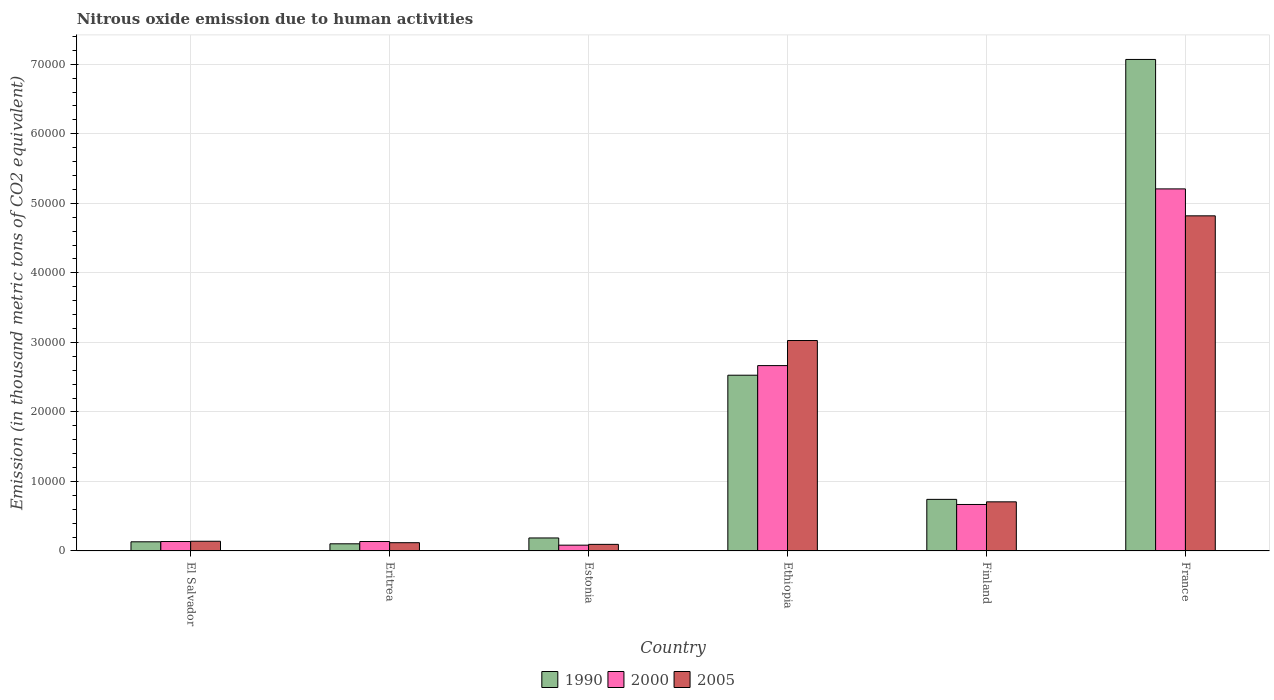How many different coloured bars are there?
Your response must be concise. 3. How many groups of bars are there?
Your response must be concise. 6. How many bars are there on the 5th tick from the left?
Your answer should be very brief. 3. How many bars are there on the 6th tick from the right?
Your answer should be very brief. 3. What is the label of the 1st group of bars from the left?
Your answer should be very brief. El Salvador. In how many cases, is the number of bars for a given country not equal to the number of legend labels?
Make the answer very short. 0. What is the amount of nitrous oxide emitted in 2000 in France?
Offer a very short reply. 5.21e+04. Across all countries, what is the maximum amount of nitrous oxide emitted in 2005?
Offer a very short reply. 4.82e+04. Across all countries, what is the minimum amount of nitrous oxide emitted in 2000?
Give a very brief answer. 837. In which country was the amount of nitrous oxide emitted in 1990 maximum?
Offer a very short reply. France. In which country was the amount of nitrous oxide emitted in 1990 minimum?
Your response must be concise. Eritrea. What is the total amount of nitrous oxide emitted in 2000 in the graph?
Give a very brief answer. 8.90e+04. What is the difference between the amount of nitrous oxide emitted in 2000 in El Salvador and that in Ethiopia?
Your answer should be very brief. -2.53e+04. What is the difference between the amount of nitrous oxide emitted in 2005 in Eritrea and the amount of nitrous oxide emitted in 2000 in Finland?
Keep it short and to the point. -5496.4. What is the average amount of nitrous oxide emitted in 2000 per country?
Provide a succinct answer. 1.48e+04. What is the difference between the amount of nitrous oxide emitted of/in 1990 and amount of nitrous oxide emitted of/in 2005 in Estonia?
Offer a very short reply. 921.2. What is the ratio of the amount of nitrous oxide emitted in 2005 in Finland to that in France?
Your answer should be compact. 0.15. Is the difference between the amount of nitrous oxide emitted in 1990 in El Salvador and Ethiopia greater than the difference between the amount of nitrous oxide emitted in 2005 in El Salvador and Ethiopia?
Provide a short and direct response. Yes. What is the difference between the highest and the second highest amount of nitrous oxide emitted in 2005?
Provide a succinct answer. 2.32e+04. What is the difference between the highest and the lowest amount of nitrous oxide emitted in 2005?
Your answer should be compact. 4.72e+04. How many bars are there?
Your response must be concise. 18. Are all the bars in the graph horizontal?
Make the answer very short. No. Are the values on the major ticks of Y-axis written in scientific E-notation?
Give a very brief answer. No. Does the graph contain any zero values?
Make the answer very short. No. How many legend labels are there?
Your answer should be very brief. 3. What is the title of the graph?
Make the answer very short. Nitrous oxide emission due to human activities. Does "1989" appear as one of the legend labels in the graph?
Offer a terse response. No. What is the label or title of the Y-axis?
Provide a succinct answer. Emission (in thousand metric tons of CO2 equivalent). What is the Emission (in thousand metric tons of CO2 equivalent) of 1990 in El Salvador?
Offer a very short reply. 1319.4. What is the Emission (in thousand metric tons of CO2 equivalent) of 2000 in El Salvador?
Your response must be concise. 1359.1. What is the Emission (in thousand metric tons of CO2 equivalent) in 2005 in El Salvador?
Your answer should be very brief. 1398.9. What is the Emission (in thousand metric tons of CO2 equivalent) in 1990 in Eritrea?
Your answer should be very brief. 1030.6. What is the Emission (in thousand metric tons of CO2 equivalent) in 2000 in Eritrea?
Offer a terse response. 1360.3. What is the Emission (in thousand metric tons of CO2 equivalent) of 2005 in Eritrea?
Provide a succinct answer. 1191.7. What is the Emission (in thousand metric tons of CO2 equivalent) of 1990 in Estonia?
Your answer should be very brief. 1872.9. What is the Emission (in thousand metric tons of CO2 equivalent) in 2000 in Estonia?
Provide a succinct answer. 837. What is the Emission (in thousand metric tons of CO2 equivalent) in 2005 in Estonia?
Ensure brevity in your answer.  951.7. What is the Emission (in thousand metric tons of CO2 equivalent) of 1990 in Ethiopia?
Your response must be concise. 2.53e+04. What is the Emission (in thousand metric tons of CO2 equivalent) in 2000 in Ethiopia?
Offer a terse response. 2.67e+04. What is the Emission (in thousand metric tons of CO2 equivalent) of 2005 in Ethiopia?
Offer a very short reply. 3.03e+04. What is the Emission (in thousand metric tons of CO2 equivalent) in 1990 in Finland?
Your answer should be very brief. 7423. What is the Emission (in thousand metric tons of CO2 equivalent) in 2000 in Finland?
Offer a very short reply. 6688.1. What is the Emission (in thousand metric tons of CO2 equivalent) of 2005 in Finland?
Provide a succinct answer. 7068. What is the Emission (in thousand metric tons of CO2 equivalent) of 1990 in France?
Your answer should be very brief. 7.07e+04. What is the Emission (in thousand metric tons of CO2 equivalent) of 2000 in France?
Your answer should be compact. 5.21e+04. What is the Emission (in thousand metric tons of CO2 equivalent) in 2005 in France?
Keep it short and to the point. 4.82e+04. Across all countries, what is the maximum Emission (in thousand metric tons of CO2 equivalent) of 1990?
Your response must be concise. 7.07e+04. Across all countries, what is the maximum Emission (in thousand metric tons of CO2 equivalent) of 2000?
Offer a very short reply. 5.21e+04. Across all countries, what is the maximum Emission (in thousand metric tons of CO2 equivalent) in 2005?
Give a very brief answer. 4.82e+04. Across all countries, what is the minimum Emission (in thousand metric tons of CO2 equivalent) in 1990?
Give a very brief answer. 1030.6. Across all countries, what is the minimum Emission (in thousand metric tons of CO2 equivalent) of 2000?
Your answer should be very brief. 837. Across all countries, what is the minimum Emission (in thousand metric tons of CO2 equivalent) in 2005?
Make the answer very short. 951.7. What is the total Emission (in thousand metric tons of CO2 equivalent) in 1990 in the graph?
Your answer should be very brief. 1.08e+05. What is the total Emission (in thousand metric tons of CO2 equivalent) in 2000 in the graph?
Offer a very short reply. 8.90e+04. What is the total Emission (in thousand metric tons of CO2 equivalent) of 2005 in the graph?
Your response must be concise. 8.91e+04. What is the difference between the Emission (in thousand metric tons of CO2 equivalent) in 1990 in El Salvador and that in Eritrea?
Your response must be concise. 288.8. What is the difference between the Emission (in thousand metric tons of CO2 equivalent) in 2000 in El Salvador and that in Eritrea?
Your answer should be compact. -1.2. What is the difference between the Emission (in thousand metric tons of CO2 equivalent) of 2005 in El Salvador and that in Eritrea?
Your answer should be compact. 207.2. What is the difference between the Emission (in thousand metric tons of CO2 equivalent) of 1990 in El Salvador and that in Estonia?
Provide a short and direct response. -553.5. What is the difference between the Emission (in thousand metric tons of CO2 equivalent) in 2000 in El Salvador and that in Estonia?
Offer a very short reply. 522.1. What is the difference between the Emission (in thousand metric tons of CO2 equivalent) of 2005 in El Salvador and that in Estonia?
Make the answer very short. 447.2. What is the difference between the Emission (in thousand metric tons of CO2 equivalent) of 1990 in El Salvador and that in Ethiopia?
Your answer should be compact. -2.40e+04. What is the difference between the Emission (in thousand metric tons of CO2 equivalent) of 2000 in El Salvador and that in Ethiopia?
Provide a short and direct response. -2.53e+04. What is the difference between the Emission (in thousand metric tons of CO2 equivalent) of 2005 in El Salvador and that in Ethiopia?
Provide a succinct answer. -2.89e+04. What is the difference between the Emission (in thousand metric tons of CO2 equivalent) in 1990 in El Salvador and that in Finland?
Your answer should be very brief. -6103.6. What is the difference between the Emission (in thousand metric tons of CO2 equivalent) in 2000 in El Salvador and that in Finland?
Offer a terse response. -5329. What is the difference between the Emission (in thousand metric tons of CO2 equivalent) of 2005 in El Salvador and that in Finland?
Make the answer very short. -5669.1. What is the difference between the Emission (in thousand metric tons of CO2 equivalent) of 1990 in El Salvador and that in France?
Ensure brevity in your answer.  -6.94e+04. What is the difference between the Emission (in thousand metric tons of CO2 equivalent) of 2000 in El Salvador and that in France?
Offer a very short reply. -5.07e+04. What is the difference between the Emission (in thousand metric tons of CO2 equivalent) in 2005 in El Salvador and that in France?
Keep it short and to the point. -4.68e+04. What is the difference between the Emission (in thousand metric tons of CO2 equivalent) of 1990 in Eritrea and that in Estonia?
Your answer should be compact. -842.3. What is the difference between the Emission (in thousand metric tons of CO2 equivalent) in 2000 in Eritrea and that in Estonia?
Your answer should be compact. 523.3. What is the difference between the Emission (in thousand metric tons of CO2 equivalent) of 2005 in Eritrea and that in Estonia?
Provide a succinct answer. 240. What is the difference between the Emission (in thousand metric tons of CO2 equivalent) of 1990 in Eritrea and that in Ethiopia?
Provide a short and direct response. -2.42e+04. What is the difference between the Emission (in thousand metric tons of CO2 equivalent) in 2000 in Eritrea and that in Ethiopia?
Keep it short and to the point. -2.53e+04. What is the difference between the Emission (in thousand metric tons of CO2 equivalent) in 2005 in Eritrea and that in Ethiopia?
Ensure brevity in your answer.  -2.91e+04. What is the difference between the Emission (in thousand metric tons of CO2 equivalent) in 1990 in Eritrea and that in Finland?
Provide a short and direct response. -6392.4. What is the difference between the Emission (in thousand metric tons of CO2 equivalent) in 2000 in Eritrea and that in Finland?
Provide a short and direct response. -5327.8. What is the difference between the Emission (in thousand metric tons of CO2 equivalent) in 2005 in Eritrea and that in Finland?
Provide a short and direct response. -5876.3. What is the difference between the Emission (in thousand metric tons of CO2 equivalent) in 1990 in Eritrea and that in France?
Give a very brief answer. -6.97e+04. What is the difference between the Emission (in thousand metric tons of CO2 equivalent) in 2000 in Eritrea and that in France?
Your response must be concise. -5.07e+04. What is the difference between the Emission (in thousand metric tons of CO2 equivalent) of 2005 in Eritrea and that in France?
Make the answer very short. -4.70e+04. What is the difference between the Emission (in thousand metric tons of CO2 equivalent) in 1990 in Estonia and that in Ethiopia?
Make the answer very short. -2.34e+04. What is the difference between the Emission (in thousand metric tons of CO2 equivalent) in 2000 in Estonia and that in Ethiopia?
Your response must be concise. -2.58e+04. What is the difference between the Emission (in thousand metric tons of CO2 equivalent) in 2005 in Estonia and that in Ethiopia?
Your answer should be very brief. -2.93e+04. What is the difference between the Emission (in thousand metric tons of CO2 equivalent) in 1990 in Estonia and that in Finland?
Give a very brief answer. -5550.1. What is the difference between the Emission (in thousand metric tons of CO2 equivalent) of 2000 in Estonia and that in Finland?
Offer a terse response. -5851.1. What is the difference between the Emission (in thousand metric tons of CO2 equivalent) of 2005 in Estonia and that in Finland?
Your answer should be very brief. -6116.3. What is the difference between the Emission (in thousand metric tons of CO2 equivalent) in 1990 in Estonia and that in France?
Provide a succinct answer. -6.88e+04. What is the difference between the Emission (in thousand metric tons of CO2 equivalent) in 2000 in Estonia and that in France?
Offer a terse response. -5.12e+04. What is the difference between the Emission (in thousand metric tons of CO2 equivalent) in 2005 in Estonia and that in France?
Offer a terse response. -4.72e+04. What is the difference between the Emission (in thousand metric tons of CO2 equivalent) of 1990 in Ethiopia and that in Finland?
Your response must be concise. 1.79e+04. What is the difference between the Emission (in thousand metric tons of CO2 equivalent) of 2000 in Ethiopia and that in Finland?
Your answer should be compact. 2.00e+04. What is the difference between the Emission (in thousand metric tons of CO2 equivalent) in 2005 in Ethiopia and that in Finland?
Offer a very short reply. 2.32e+04. What is the difference between the Emission (in thousand metric tons of CO2 equivalent) in 1990 in Ethiopia and that in France?
Keep it short and to the point. -4.54e+04. What is the difference between the Emission (in thousand metric tons of CO2 equivalent) of 2000 in Ethiopia and that in France?
Keep it short and to the point. -2.54e+04. What is the difference between the Emission (in thousand metric tons of CO2 equivalent) of 2005 in Ethiopia and that in France?
Ensure brevity in your answer.  -1.79e+04. What is the difference between the Emission (in thousand metric tons of CO2 equivalent) of 1990 in Finland and that in France?
Provide a succinct answer. -6.33e+04. What is the difference between the Emission (in thousand metric tons of CO2 equivalent) of 2000 in Finland and that in France?
Your answer should be compact. -4.54e+04. What is the difference between the Emission (in thousand metric tons of CO2 equivalent) of 2005 in Finland and that in France?
Your response must be concise. -4.11e+04. What is the difference between the Emission (in thousand metric tons of CO2 equivalent) in 1990 in El Salvador and the Emission (in thousand metric tons of CO2 equivalent) in 2000 in Eritrea?
Give a very brief answer. -40.9. What is the difference between the Emission (in thousand metric tons of CO2 equivalent) in 1990 in El Salvador and the Emission (in thousand metric tons of CO2 equivalent) in 2005 in Eritrea?
Provide a short and direct response. 127.7. What is the difference between the Emission (in thousand metric tons of CO2 equivalent) of 2000 in El Salvador and the Emission (in thousand metric tons of CO2 equivalent) of 2005 in Eritrea?
Provide a succinct answer. 167.4. What is the difference between the Emission (in thousand metric tons of CO2 equivalent) of 1990 in El Salvador and the Emission (in thousand metric tons of CO2 equivalent) of 2000 in Estonia?
Provide a succinct answer. 482.4. What is the difference between the Emission (in thousand metric tons of CO2 equivalent) of 1990 in El Salvador and the Emission (in thousand metric tons of CO2 equivalent) of 2005 in Estonia?
Keep it short and to the point. 367.7. What is the difference between the Emission (in thousand metric tons of CO2 equivalent) in 2000 in El Salvador and the Emission (in thousand metric tons of CO2 equivalent) in 2005 in Estonia?
Your response must be concise. 407.4. What is the difference between the Emission (in thousand metric tons of CO2 equivalent) in 1990 in El Salvador and the Emission (in thousand metric tons of CO2 equivalent) in 2000 in Ethiopia?
Your answer should be very brief. -2.53e+04. What is the difference between the Emission (in thousand metric tons of CO2 equivalent) of 1990 in El Salvador and the Emission (in thousand metric tons of CO2 equivalent) of 2005 in Ethiopia?
Your answer should be compact. -2.89e+04. What is the difference between the Emission (in thousand metric tons of CO2 equivalent) in 2000 in El Salvador and the Emission (in thousand metric tons of CO2 equivalent) in 2005 in Ethiopia?
Provide a succinct answer. -2.89e+04. What is the difference between the Emission (in thousand metric tons of CO2 equivalent) of 1990 in El Salvador and the Emission (in thousand metric tons of CO2 equivalent) of 2000 in Finland?
Keep it short and to the point. -5368.7. What is the difference between the Emission (in thousand metric tons of CO2 equivalent) of 1990 in El Salvador and the Emission (in thousand metric tons of CO2 equivalent) of 2005 in Finland?
Your response must be concise. -5748.6. What is the difference between the Emission (in thousand metric tons of CO2 equivalent) in 2000 in El Salvador and the Emission (in thousand metric tons of CO2 equivalent) in 2005 in Finland?
Provide a succinct answer. -5708.9. What is the difference between the Emission (in thousand metric tons of CO2 equivalent) of 1990 in El Salvador and the Emission (in thousand metric tons of CO2 equivalent) of 2000 in France?
Make the answer very short. -5.08e+04. What is the difference between the Emission (in thousand metric tons of CO2 equivalent) of 1990 in El Salvador and the Emission (in thousand metric tons of CO2 equivalent) of 2005 in France?
Ensure brevity in your answer.  -4.69e+04. What is the difference between the Emission (in thousand metric tons of CO2 equivalent) in 2000 in El Salvador and the Emission (in thousand metric tons of CO2 equivalent) in 2005 in France?
Your answer should be very brief. -4.68e+04. What is the difference between the Emission (in thousand metric tons of CO2 equivalent) of 1990 in Eritrea and the Emission (in thousand metric tons of CO2 equivalent) of 2000 in Estonia?
Provide a short and direct response. 193.6. What is the difference between the Emission (in thousand metric tons of CO2 equivalent) in 1990 in Eritrea and the Emission (in thousand metric tons of CO2 equivalent) in 2005 in Estonia?
Provide a succinct answer. 78.9. What is the difference between the Emission (in thousand metric tons of CO2 equivalent) in 2000 in Eritrea and the Emission (in thousand metric tons of CO2 equivalent) in 2005 in Estonia?
Give a very brief answer. 408.6. What is the difference between the Emission (in thousand metric tons of CO2 equivalent) in 1990 in Eritrea and the Emission (in thousand metric tons of CO2 equivalent) in 2000 in Ethiopia?
Ensure brevity in your answer.  -2.56e+04. What is the difference between the Emission (in thousand metric tons of CO2 equivalent) of 1990 in Eritrea and the Emission (in thousand metric tons of CO2 equivalent) of 2005 in Ethiopia?
Your response must be concise. -2.92e+04. What is the difference between the Emission (in thousand metric tons of CO2 equivalent) of 2000 in Eritrea and the Emission (in thousand metric tons of CO2 equivalent) of 2005 in Ethiopia?
Your answer should be very brief. -2.89e+04. What is the difference between the Emission (in thousand metric tons of CO2 equivalent) in 1990 in Eritrea and the Emission (in thousand metric tons of CO2 equivalent) in 2000 in Finland?
Offer a terse response. -5657.5. What is the difference between the Emission (in thousand metric tons of CO2 equivalent) in 1990 in Eritrea and the Emission (in thousand metric tons of CO2 equivalent) in 2005 in Finland?
Keep it short and to the point. -6037.4. What is the difference between the Emission (in thousand metric tons of CO2 equivalent) in 2000 in Eritrea and the Emission (in thousand metric tons of CO2 equivalent) in 2005 in Finland?
Provide a succinct answer. -5707.7. What is the difference between the Emission (in thousand metric tons of CO2 equivalent) of 1990 in Eritrea and the Emission (in thousand metric tons of CO2 equivalent) of 2000 in France?
Provide a short and direct response. -5.10e+04. What is the difference between the Emission (in thousand metric tons of CO2 equivalent) in 1990 in Eritrea and the Emission (in thousand metric tons of CO2 equivalent) in 2005 in France?
Make the answer very short. -4.72e+04. What is the difference between the Emission (in thousand metric tons of CO2 equivalent) in 2000 in Eritrea and the Emission (in thousand metric tons of CO2 equivalent) in 2005 in France?
Give a very brief answer. -4.68e+04. What is the difference between the Emission (in thousand metric tons of CO2 equivalent) of 1990 in Estonia and the Emission (in thousand metric tons of CO2 equivalent) of 2000 in Ethiopia?
Offer a terse response. -2.48e+04. What is the difference between the Emission (in thousand metric tons of CO2 equivalent) in 1990 in Estonia and the Emission (in thousand metric tons of CO2 equivalent) in 2005 in Ethiopia?
Give a very brief answer. -2.84e+04. What is the difference between the Emission (in thousand metric tons of CO2 equivalent) in 2000 in Estonia and the Emission (in thousand metric tons of CO2 equivalent) in 2005 in Ethiopia?
Your answer should be compact. -2.94e+04. What is the difference between the Emission (in thousand metric tons of CO2 equivalent) of 1990 in Estonia and the Emission (in thousand metric tons of CO2 equivalent) of 2000 in Finland?
Keep it short and to the point. -4815.2. What is the difference between the Emission (in thousand metric tons of CO2 equivalent) of 1990 in Estonia and the Emission (in thousand metric tons of CO2 equivalent) of 2005 in Finland?
Offer a terse response. -5195.1. What is the difference between the Emission (in thousand metric tons of CO2 equivalent) in 2000 in Estonia and the Emission (in thousand metric tons of CO2 equivalent) in 2005 in Finland?
Ensure brevity in your answer.  -6231. What is the difference between the Emission (in thousand metric tons of CO2 equivalent) in 1990 in Estonia and the Emission (in thousand metric tons of CO2 equivalent) in 2000 in France?
Your response must be concise. -5.02e+04. What is the difference between the Emission (in thousand metric tons of CO2 equivalent) in 1990 in Estonia and the Emission (in thousand metric tons of CO2 equivalent) in 2005 in France?
Offer a terse response. -4.63e+04. What is the difference between the Emission (in thousand metric tons of CO2 equivalent) in 2000 in Estonia and the Emission (in thousand metric tons of CO2 equivalent) in 2005 in France?
Give a very brief answer. -4.74e+04. What is the difference between the Emission (in thousand metric tons of CO2 equivalent) of 1990 in Ethiopia and the Emission (in thousand metric tons of CO2 equivalent) of 2000 in Finland?
Give a very brief answer. 1.86e+04. What is the difference between the Emission (in thousand metric tons of CO2 equivalent) in 1990 in Ethiopia and the Emission (in thousand metric tons of CO2 equivalent) in 2005 in Finland?
Offer a terse response. 1.82e+04. What is the difference between the Emission (in thousand metric tons of CO2 equivalent) of 2000 in Ethiopia and the Emission (in thousand metric tons of CO2 equivalent) of 2005 in Finland?
Ensure brevity in your answer.  1.96e+04. What is the difference between the Emission (in thousand metric tons of CO2 equivalent) of 1990 in Ethiopia and the Emission (in thousand metric tons of CO2 equivalent) of 2000 in France?
Offer a terse response. -2.68e+04. What is the difference between the Emission (in thousand metric tons of CO2 equivalent) in 1990 in Ethiopia and the Emission (in thousand metric tons of CO2 equivalent) in 2005 in France?
Make the answer very short. -2.29e+04. What is the difference between the Emission (in thousand metric tons of CO2 equivalent) in 2000 in Ethiopia and the Emission (in thousand metric tons of CO2 equivalent) in 2005 in France?
Give a very brief answer. -2.15e+04. What is the difference between the Emission (in thousand metric tons of CO2 equivalent) in 1990 in Finland and the Emission (in thousand metric tons of CO2 equivalent) in 2000 in France?
Provide a short and direct response. -4.47e+04. What is the difference between the Emission (in thousand metric tons of CO2 equivalent) in 1990 in Finland and the Emission (in thousand metric tons of CO2 equivalent) in 2005 in France?
Ensure brevity in your answer.  -4.08e+04. What is the difference between the Emission (in thousand metric tons of CO2 equivalent) of 2000 in Finland and the Emission (in thousand metric tons of CO2 equivalent) of 2005 in France?
Offer a terse response. -4.15e+04. What is the average Emission (in thousand metric tons of CO2 equivalent) in 1990 per country?
Your response must be concise. 1.79e+04. What is the average Emission (in thousand metric tons of CO2 equivalent) in 2000 per country?
Your answer should be very brief. 1.48e+04. What is the average Emission (in thousand metric tons of CO2 equivalent) in 2005 per country?
Offer a terse response. 1.48e+04. What is the difference between the Emission (in thousand metric tons of CO2 equivalent) in 1990 and Emission (in thousand metric tons of CO2 equivalent) in 2000 in El Salvador?
Ensure brevity in your answer.  -39.7. What is the difference between the Emission (in thousand metric tons of CO2 equivalent) in 1990 and Emission (in thousand metric tons of CO2 equivalent) in 2005 in El Salvador?
Your answer should be compact. -79.5. What is the difference between the Emission (in thousand metric tons of CO2 equivalent) of 2000 and Emission (in thousand metric tons of CO2 equivalent) of 2005 in El Salvador?
Provide a short and direct response. -39.8. What is the difference between the Emission (in thousand metric tons of CO2 equivalent) of 1990 and Emission (in thousand metric tons of CO2 equivalent) of 2000 in Eritrea?
Provide a short and direct response. -329.7. What is the difference between the Emission (in thousand metric tons of CO2 equivalent) of 1990 and Emission (in thousand metric tons of CO2 equivalent) of 2005 in Eritrea?
Your response must be concise. -161.1. What is the difference between the Emission (in thousand metric tons of CO2 equivalent) of 2000 and Emission (in thousand metric tons of CO2 equivalent) of 2005 in Eritrea?
Ensure brevity in your answer.  168.6. What is the difference between the Emission (in thousand metric tons of CO2 equivalent) of 1990 and Emission (in thousand metric tons of CO2 equivalent) of 2000 in Estonia?
Keep it short and to the point. 1035.9. What is the difference between the Emission (in thousand metric tons of CO2 equivalent) in 1990 and Emission (in thousand metric tons of CO2 equivalent) in 2005 in Estonia?
Your response must be concise. 921.2. What is the difference between the Emission (in thousand metric tons of CO2 equivalent) of 2000 and Emission (in thousand metric tons of CO2 equivalent) of 2005 in Estonia?
Make the answer very short. -114.7. What is the difference between the Emission (in thousand metric tons of CO2 equivalent) of 1990 and Emission (in thousand metric tons of CO2 equivalent) of 2000 in Ethiopia?
Keep it short and to the point. -1381.9. What is the difference between the Emission (in thousand metric tons of CO2 equivalent) in 1990 and Emission (in thousand metric tons of CO2 equivalent) in 2005 in Ethiopia?
Your response must be concise. -4988.6. What is the difference between the Emission (in thousand metric tons of CO2 equivalent) of 2000 and Emission (in thousand metric tons of CO2 equivalent) of 2005 in Ethiopia?
Ensure brevity in your answer.  -3606.7. What is the difference between the Emission (in thousand metric tons of CO2 equivalent) of 1990 and Emission (in thousand metric tons of CO2 equivalent) of 2000 in Finland?
Ensure brevity in your answer.  734.9. What is the difference between the Emission (in thousand metric tons of CO2 equivalent) of 1990 and Emission (in thousand metric tons of CO2 equivalent) of 2005 in Finland?
Provide a succinct answer. 355. What is the difference between the Emission (in thousand metric tons of CO2 equivalent) in 2000 and Emission (in thousand metric tons of CO2 equivalent) in 2005 in Finland?
Your response must be concise. -379.9. What is the difference between the Emission (in thousand metric tons of CO2 equivalent) in 1990 and Emission (in thousand metric tons of CO2 equivalent) in 2000 in France?
Provide a succinct answer. 1.86e+04. What is the difference between the Emission (in thousand metric tons of CO2 equivalent) of 1990 and Emission (in thousand metric tons of CO2 equivalent) of 2005 in France?
Offer a terse response. 2.25e+04. What is the difference between the Emission (in thousand metric tons of CO2 equivalent) of 2000 and Emission (in thousand metric tons of CO2 equivalent) of 2005 in France?
Your answer should be very brief. 3875.3. What is the ratio of the Emission (in thousand metric tons of CO2 equivalent) in 1990 in El Salvador to that in Eritrea?
Offer a terse response. 1.28. What is the ratio of the Emission (in thousand metric tons of CO2 equivalent) in 2000 in El Salvador to that in Eritrea?
Provide a short and direct response. 1. What is the ratio of the Emission (in thousand metric tons of CO2 equivalent) in 2005 in El Salvador to that in Eritrea?
Keep it short and to the point. 1.17. What is the ratio of the Emission (in thousand metric tons of CO2 equivalent) in 1990 in El Salvador to that in Estonia?
Your answer should be very brief. 0.7. What is the ratio of the Emission (in thousand metric tons of CO2 equivalent) of 2000 in El Salvador to that in Estonia?
Offer a very short reply. 1.62. What is the ratio of the Emission (in thousand metric tons of CO2 equivalent) in 2005 in El Salvador to that in Estonia?
Provide a succinct answer. 1.47. What is the ratio of the Emission (in thousand metric tons of CO2 equivalent) of 1990 in El Salvador to that in Ethiopia?
Give a very brief answer. 0.05. What is the ratio of the Emission (in thousand metric tons of CO2 equivalent) of 2000 in El Salvador to that in Ethiopia?
Offer a very short reply. 0.05. What is the ratio of the Emission (in thousand metric tons of CO2 equivalent) in 2005 in El Salvador to that in Ethiopia?
Give a very brief answer. 0.05. What is the ratio of the Emission (in thousand metric tons of CO2 equivalent) of 1990 in El Salvador to that in Finland?
Your response must be concise. 0.18. What is the ratio of the Emission (in thousand metric tons of CO2 equivalent) in 2000 in El Salvador to that in Finland?
Give a very brief answer. 0.2. What is the ratio of the Emission (in thousand metric tons of CO2 equivalent) in 2005 in El Salvador to that in Finland?
Provide a short and direct response. 0.2. What is the ratio of the Emission (in thousand metric tons of CO2 equivalent) in 1990 in El Salvador to that in France?
Make the answer very short. 0.02. What is the ratio of the Emission (in thousand metric tons of CO2 equivalent) in 2000 in El Salvador to that in France?
Give a very brief answer. 0.03. What is the ratio of the Emission (in thousand metric tons of CO2 equivalent) in 2005 in El Salvador to that in France?
Offer a very short reply. 0.03. What is the ratio of the Emission (in thousand metric tons of CO2 equivalent) in 1990 in Eritrea to that in Estonia?
Your response must be concise. 0.55. What is the ratio of the Emission (in thousand metric tons of CO2 equivalent) in 2000 in Eritrea to that in Estonia?
Give a very brief answer. 1.63. What is the ratio of the Emission (in thousand metric tons of CO2 equivalent) of 2005 in Eritrea to that in Estonia?
Offer a terse response. 1.25. What is the ratio of the Emission (in thousand metric tons of CO2 equivalent) of 1990 in Eritrea to that in Ethiopia?
Provide a short and direct response. 0.04. What is the ratio of the Emission (in thousand metric tons of CO2 equivalent) of 2000 in Eritrea to that in Ethiopia?
Give a very brief answer. 0.05. What is the ratio of the Emission (in thousand metric tons of CO2 equivalent) in 2005 in Eritrea to that in Ethiopia?
Ensure brevity in your answer.  0.04. What is the ratio of the Emission (in thousand metric tons of CO2 equivalent) of 1990 in Eritrea to that in Finland?
Give a very brief answer. 0.14. What is the ratio of the Emission (in thousand metric tons of CO2 equivalent) of 2000 in Eritrea to that in Finland?
Make the answer very short. 0.2. What is the ratio of the Emission (in thousand metric tons of CO2 equivalent) in 2005 in Eritrea to that in Finland?
Provide a short and direct response. 0.17. What is the ratio of the Emission (in thousand metric tons of CO2 equivalent) in 1990 in Eritrea to that in France?
Provide a succinct answer. 0.01. What is the ratio of the Emission (in thousand metric tons of CO2 equivalent) of 2000 in Eritrea to that in France?
Give a very brief answer. 0.03. What is the ratio of the Emission (in thousand metric tons of CO2 equivalent) in 2005 in Eritrea to that in France?
Offer a terse response. 0.02. What is the ratio of the Emission (in thousand metric tons of CO2 equivalent) in 1990 in Estonia to that in Ethiopia?
Provide a short and direct response. 0.07. What is the ratio of the Emission (in thousand metric tons of CO2 equivalent) of 2000 in Estonia to that in Ethiopia?
Provide a succinct answer. 0.03. What is the ratio of the Emission (in thousand metric tons of CO2 equivalent) of 2005 in Estonia to that in Ethiopia?
Give a very brief answer. 0.03. What is the ratio of the Emission (in thousand metric tons of CO2 equivalent) of 1990 in Estonia to that in Finland?
Provide a succinct answer. 0.25. What is the ratio of the Emission (in thousand metric tons of CO2 equivalent) of 2000 in Estonia to that in Finland?
Your answer should be compact. 0.13. What is the ratio of the Emission (in thousand metric tons of CO2 equivalent) of 2005 in Estonia to that in Finland?
Ensure brevity in your answer.  0.13. What is the ratio of the Emission (in thousand metric tons of CO2 equivalent) in 1990 in Estonia to that in France?
Provide a short and direct response. 0.03. What is the ratio of the Emission (in thousand metric tons of CO2 equivalent) in 2000 in Estonia to that in France?
Provide a succinct answer. 0.02. What is the ratio of the Emission (in thousand metric tons of CO2 equivalent) in 2005 in Estonia to that in France?
Provide a short and direct response. 0.02. What is the ratio of the Emission (in thousand metric tons of CO2 equivalent) in 1990 in Ethiopia to that in Finland?
Your answer should be very brief. 3.41. What is the ratio of the Emission (in thousand metric tons of CO2 equivalent) in 2000 in Ethiopia to that in Finland?
Ensure brevity in your answer.  3.99. What is the ratio of the Emission (in thousand metric tons of CO2 equivalent) in 2005 in Ethiopia to that in Finland?
Provide a succinct answer. 4.28. What is the ratio of the Emission (in thousand metric tons of CO2 equivalent) in 1990 in Ethiopia to that in France?
Provide a short and direct response. 0.36. What is the ratio of the Emission (in thousand metric tons of CO2 equivalent) of 2000 in Ethiopia to that in France?
Make the answer very short. 0.51. What is the ratio of the Emission (in thousand metric tons of CO2 equivalent) in 2005 in Ethiopia to that in France?
Offer a terse response. 0.63. What is the ratio of the Emission (in thousand metric tons of CO2 equivalent) in 1990 in Finland to that in France?
Make the answer very short. 0.1. What is the ratio of the Emission (in thousand metric tons of CO2 equivalent) of 2000 in Finland to that in France?
Give a very brief answer. 0.13. What is the ratio of the Emission (in thousand metric tons of CO2 equivalent) of 2005 in Finland to that in France?
Give a very brief answer. 0.15. What is the difference between the highest and the second highest Emission (in thousand metric tons of CO2 equivalent) in 1990?
Give a very brief answer. 4.54e+04. What is the difference between the highest and the second highest Emission (in thousand metric tons of CO2 equivalent) in 2000?
Give a very brief answer. 2.54e+04. What is the difference between the highest and the second highest Emission (in thousand metric tons of CO2 equivalent) in 2005?
Provide a short and direct response. 1.79e+04. What is the difference between the highest and the lowest Emission (in thousand metric tons of CO2 equivalent) in 1990?
Your answer should be very brief. 6.97e+04. What is the difference between the highest and the lowest Emission (in thousand metric tons of CO2 equivalent) of 2000?
Provide a succinct answer. 5.12e+04. What is the difference between the highest and the lowest Emission (in thousand metric tons of CO2 equivalent) of 2005?
Ensure brevity in your answer.  4.72e+04. 